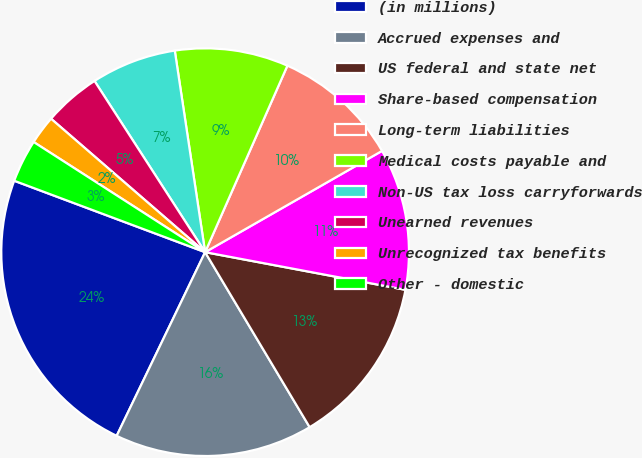Convert chart. <chart><loc_0><loc_0><loc_500><loc_500><pie_chart><fcel>(in millions)<fcel>Accrued expenses and<fcel>US federal and state net<fcel>Share-based compensation<fcel>Long-term liabilities<fcel>Medical costs payable and<fcel>Non-US tax loss carryforwards<fcel>Unearned revenues<fcel>Unrecognized tax benefits<fcel>Other - domestic<nl><fcel>23.55%<fcel>15.71%<fcel>13.47%<fcel>11.23%<fcel>10.11%<fcel>8.99%<fcel>6.75%<fcel>4.51%<fcel>2.27%<fcel>3.39%<nl></chart> 